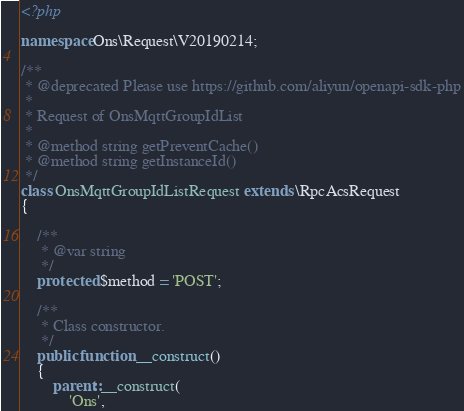<code> <loc_0><loc_0><loc_500><loc_500><_PHP_><?php

namespace Ons\Request\V20190214;

/**
 * @deprecated Please use https://github.com/aliyun/openapi-sdk-php
 *
 * Request of OnsMqttGroupIdList
 *
 * @method string getPreventCache()
 * @method string getInstanceId()
 */
class OnsMqttGroupIdListRequest extends \RpcAcsRequest
{

    /**
     * @var string
     */
    protected $method = 'POST';

    /**
     * Class constructor.
     */
    public function __construct()
    {
        parent::__construct(
            'Ons',</code> 